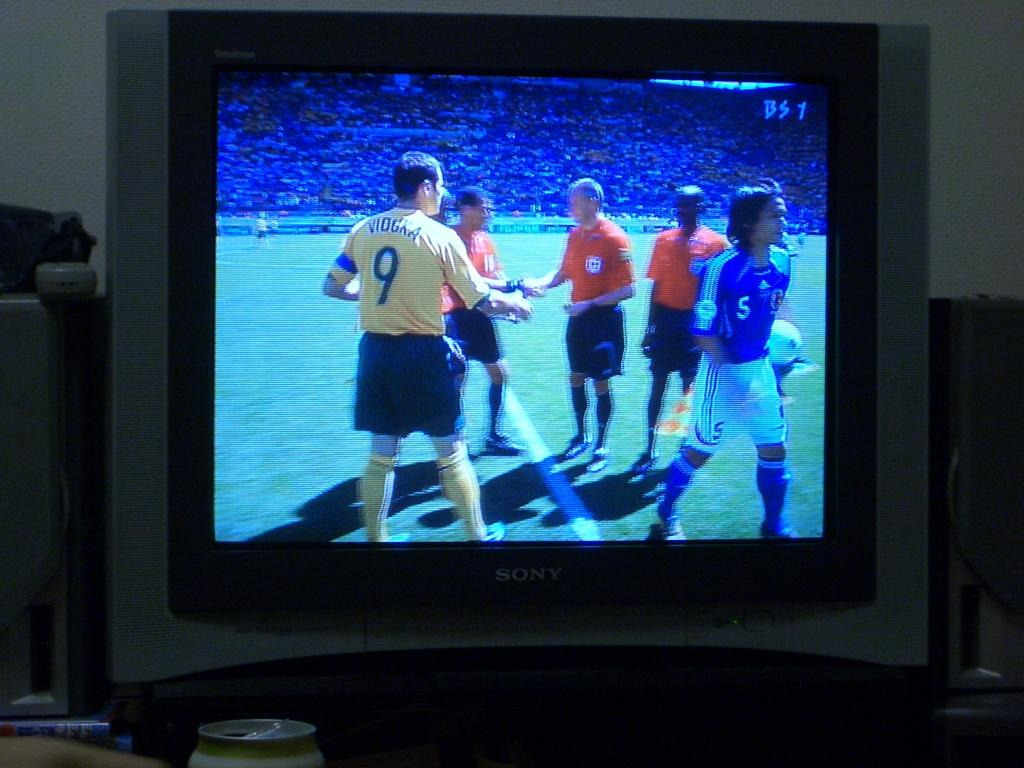<image>
Relay a brief, clear account of the picture shown. The man in the yellow jersey wears number 9 